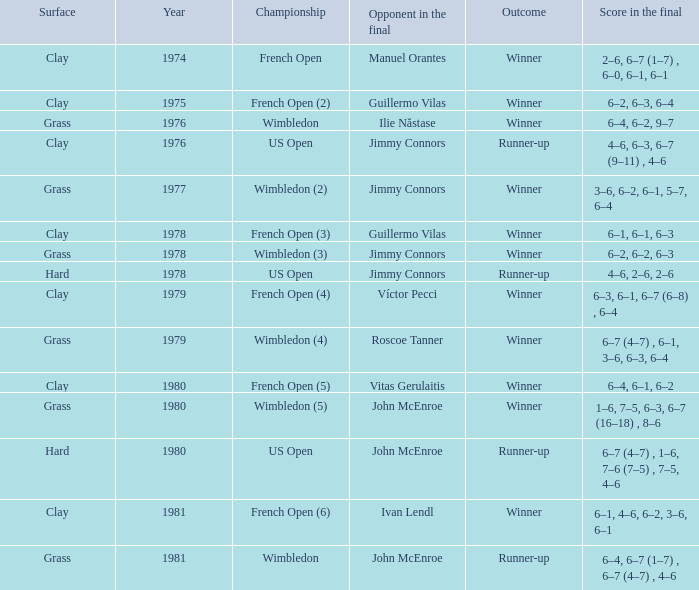What is every score in the final for opponent in final John Mcenroe at US Open? 6–7 (4–7) , 1–6, 7–6 (7–5) , 7–5, 4–6. 